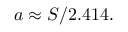Convert formula to latex. <formula><loc_0><loc_0><loc_500><loc_500>a \approx S / 2 . 4 1 4 .</formula> 